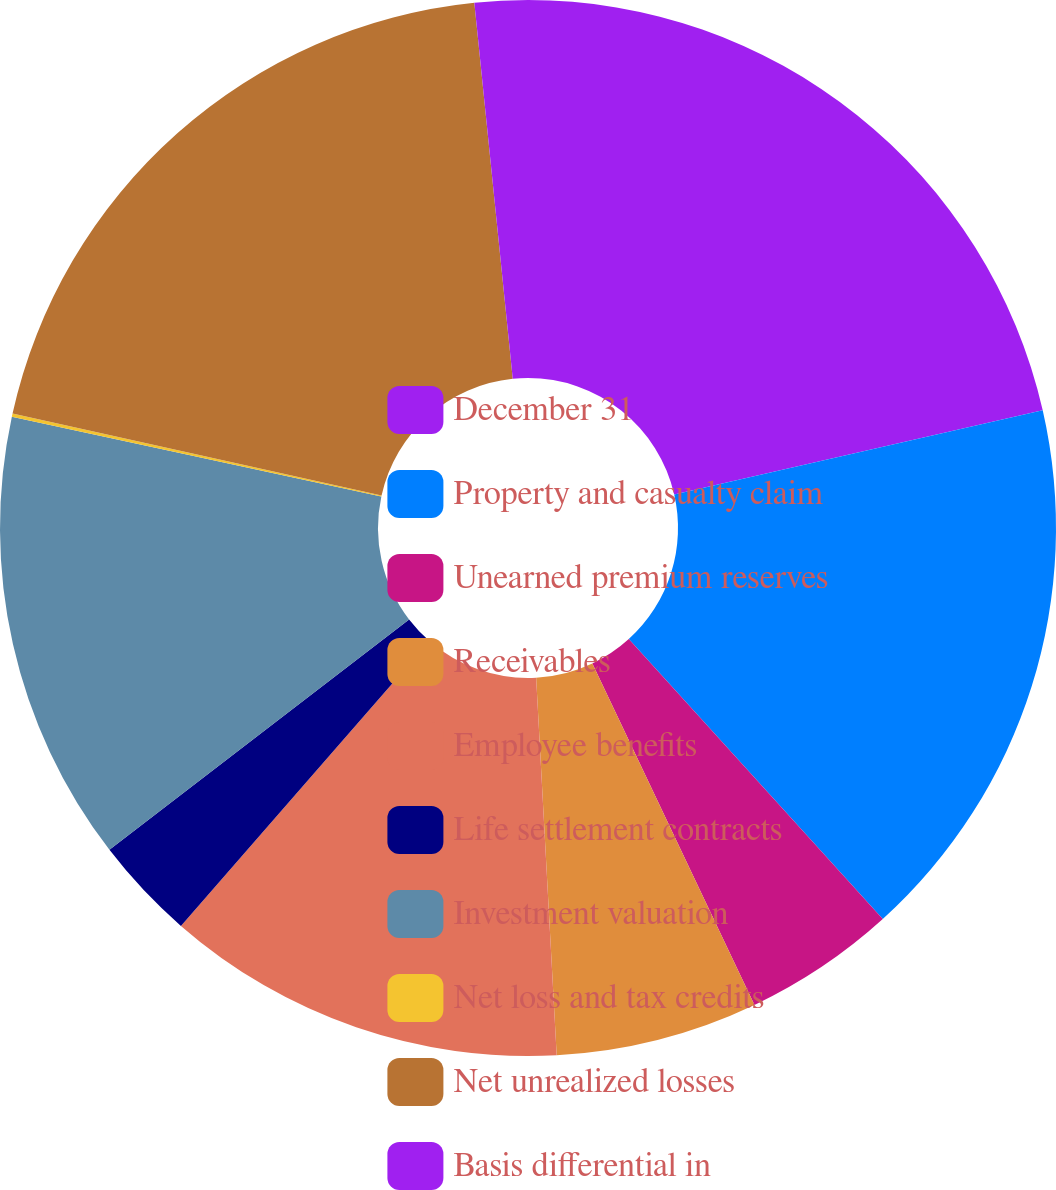<chart> <loc_0><loc_0><loc_500><loc_500><pie_chart><fcel>December 31<fcel>Property and casualty claim<fcel>Unearned premium reserves<fcel>Receivables<fcel>Employee benefits<fcel>Life settlement contracts<fcel>Investment valuation<fcel>Net loss and tax credits<fcel>Net unrealized losses<fcel>Basis differential in<nl><fcel>21.42%<fcel>16.85%<fcel>4.67%<fcel>6.19%<fcel>12.28%<fcel>3.15%<fcel>13.81%<fcel>0.1%<fcel>19.9%<fcel>1.62%<nl></chart> 